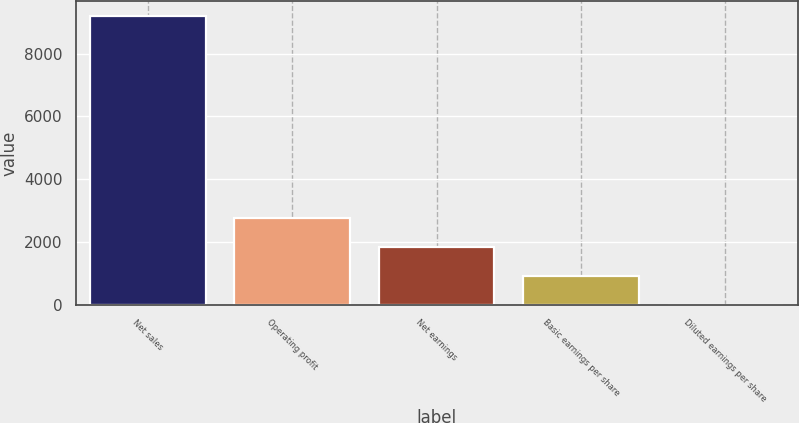<chart> <loc_0><loc_0><loc_500><loc_500><bar_chart><fcel>Net sales<fcel>Operating profit<fcel>Net earnings<fcel>Basic earnings per share<fcel>Diluted earnings per share<nl><fcel>9201<fcel>2760.96<fcel>1840.96<fcel>920.96<fcel>0.96<nl></chart> 